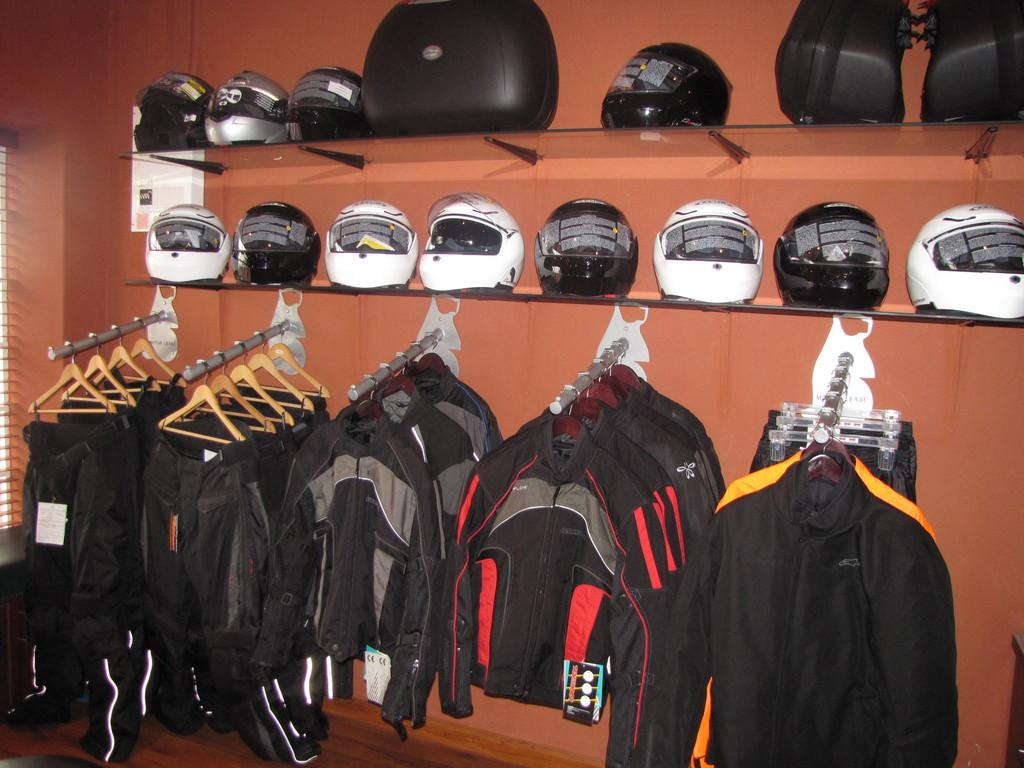What items can be seen in the front of the image? There are clothes and hangers in the front of the image. What is visible in the background of the image? There is a wall in the background of the image. What type of furniture is present in the middle of the image? There are two shelves in the middle of the image. What objects are placed on the shelves? There are helmets on the shelves. Can you see any bones or brushes in the image? No, there are no bones or brushes present in the image. Is there a yard visible in the image? No, there is no yard visible in the image; it is an indoor scene with a wall in the background. 